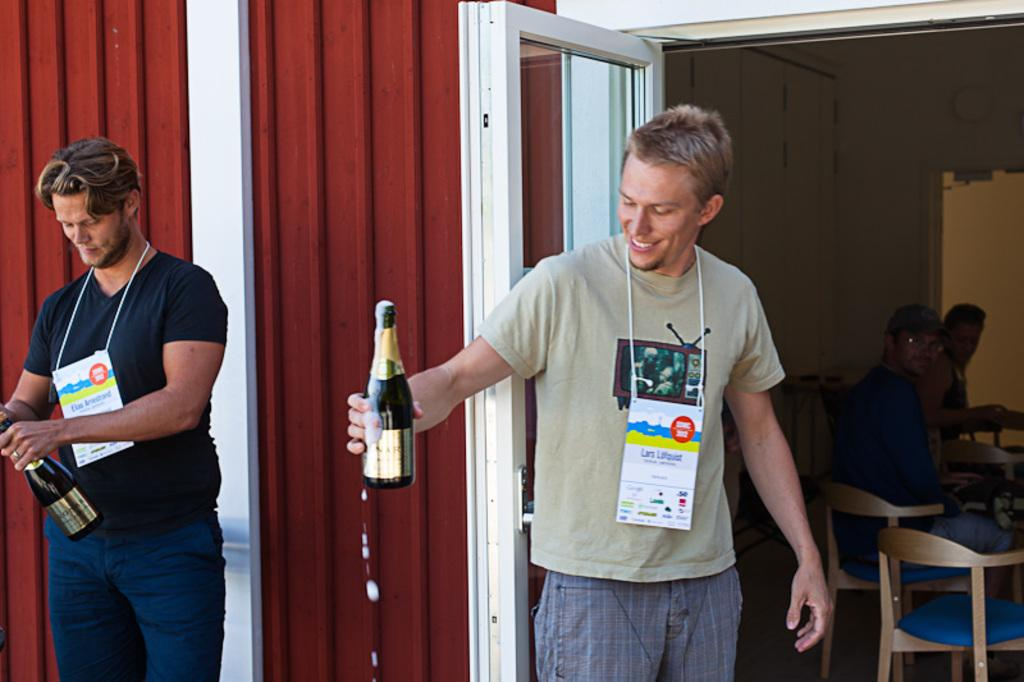What is the primary activity of the men in the image? The men in the image are standing and holding wine bottles. Can you describe the position of the people in the image? Some people are seated in the image. What might the men be doing with the wine bottles? The men might be holding the wine bottles for drinking or displaying them. Can you see any fights happening through the window in the image? There is no window present in the image, and therefore no fights can be seen through it. 